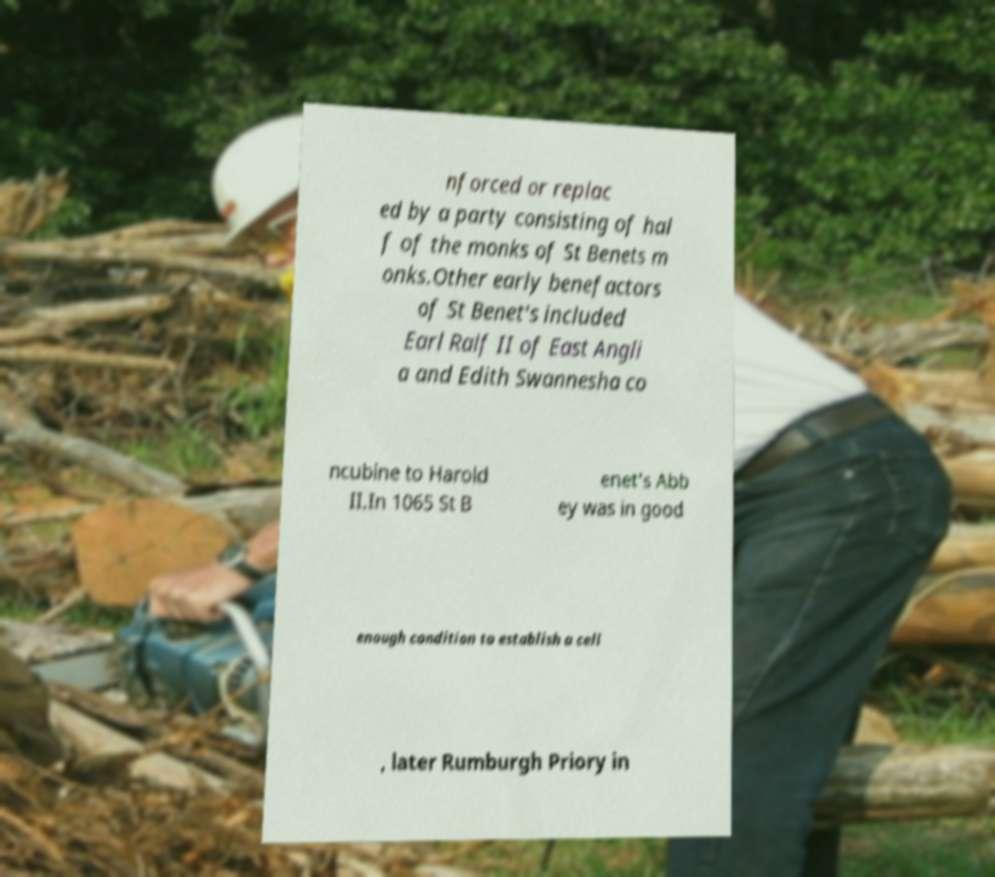Please read and relay the text visible in this image. What does it say? nforced or replac ed by a party consisting of hal f of the monks of St Benets m onks.Other early benefactors of St Benet's included Earl Ralf II of East Angli a and Edith Swannesha co ncubine to Harold II.In 1065 St B enet's Abb ey was in good enough condition to establish a cell , later Rumburgh Priory in 